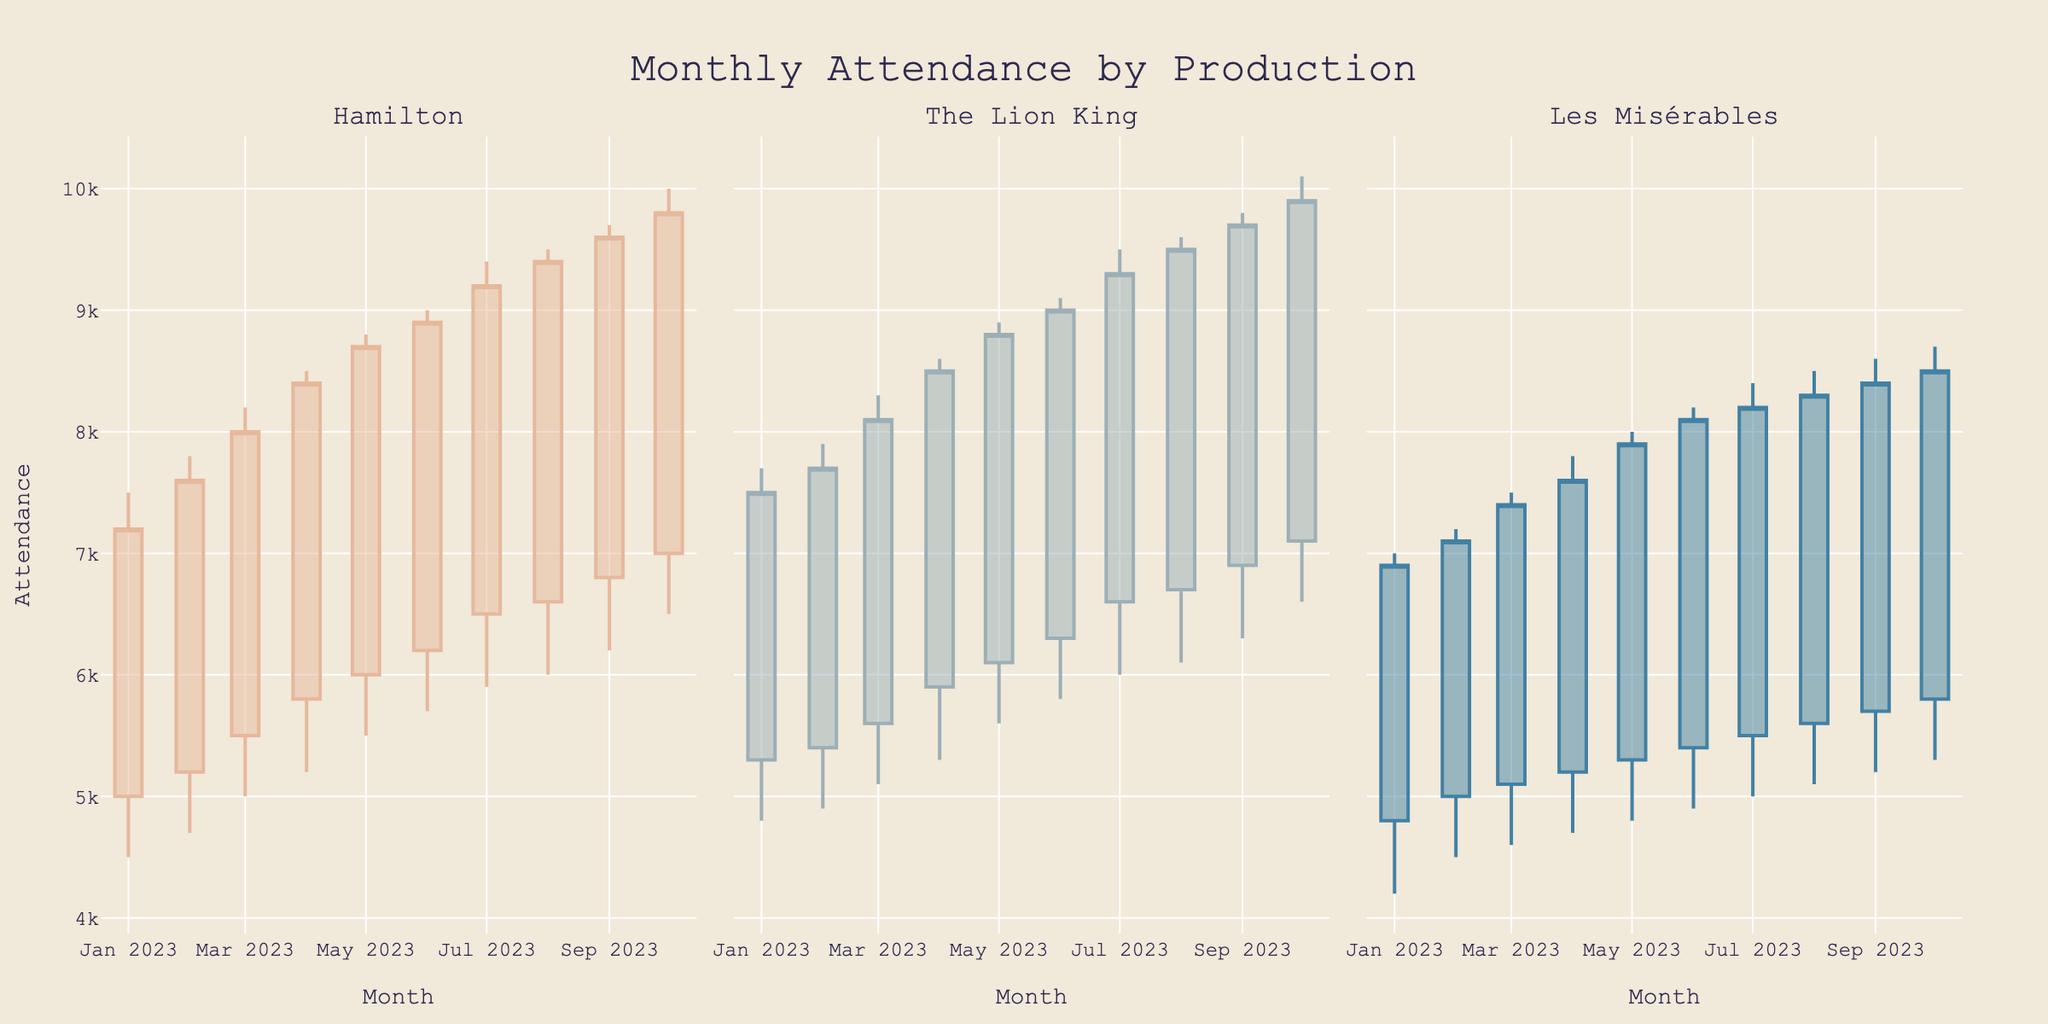what is the highest attendance recorded for Hamilton? To find the highest attendance for Hamilton, we refer to the "high" values in the candlestick plot of Hamilton. The highest value is 10000 in October 2023.
Answer: 10000 Which production had a higher close in May 2023, Hamilton or Les Misérables? To find this, compare the closing values in May 2023 for both productions. Hamilton had a close of 8700, and Les Misérables had a close of 7900. Hamilton's closing value is higher.
Answer: Hamilton In which month did The Lion King have the lowest recorded attendance? The "low" values on the candlestick plot for The Lion King must be examined. The lowest value (4800) is in January 2023.
Answer: January 2023 How many months does the data cover for each production? Data covers from January 2023 to October 2023, which totals up to 10 months for each production.
Answer: 10 months Which production had the most consistent increase in closing attendance over the months? By observing the trend of closing values on each candlestick plot, The Lion King consistently shows an increasing trend in closing attendance from January to October 2023.
Answer: The Lion King Was there any month where the attendance for all three productions increased compared to the previous month? By checking the close values month-to-month for all productions, in May 2023, the attendance for Hamilton, The Lion King, and Les Misérables all increased from April 2023.
Answer: May 2023 What's the average opening attendance for Les Misérables throughout the timeline? Add up the opening attendances for Les Misérables (4800+5000+5100+5200+5300+5400+5500+5600+5700+5800) and divide by the number of months (10). The average is (48100/10) = 4810.
Answer: 4810 Between Hamilton and The Lion King, which production had the greatest attendance volatility (difference between high and low) in July 2023? In July 2023, Hamilton had a high of 9400 and low of 5900, resulting in a volatility of 3500. The Lion King had a high of 9500 and low of 6000, resulting in a volatility of 3500. Both productions had equal volatility.
Answer: Both Which production ended October 2023 with a higher closing value? Comparing the closing values in October 2023, Hamilton closed at 9800, while The Lion King closed at 9900. The Lion King had a higher closing value.
Answer: The Lion King 